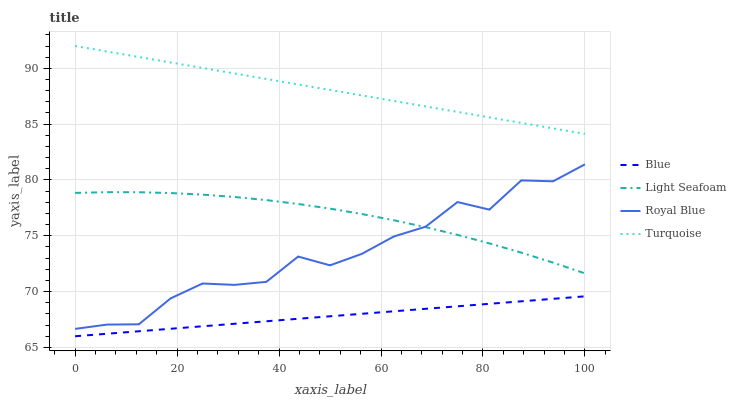Does Blue have the minimum area under the curve?
Answer yes or no. Yes. Does Turquoise have the maximum area under the curve?
Answer yes or no. Yes. Does Royal Blue have the minimum area under the curve?
Answer yes or no. No. Does Royal Blue have the maximum area under the curve?
Answer yes or no. No. Is Turquoise the smoothest?
Answer yes or no. Yes. Is Royal Blue the roughest?
Answer yes or no. Yes. Is Royal Blue the smoothest?
Answer yes or no. No. Is Turquoise the roughest?
Answer yes or no. No. Does Blue have the lowest value?
Answer yes or no. Yes. Does Royal Blue have the lowest value?
Answer yes or no. No. Does Turquoise have the highest value?
Answer yes or no. Yes. Does Royal Blue have the highest value?
Answer yes or no. No. Is Blue less than Royal Blue?
Answer yes or no. Yes. Is Turquoise greater than Blue?
Answer yes or no. Yes. Does Light Seafoam intersect Royal Blue?
Answer yes or no. Yes. Is Light Seafoam less than Royal Blue?
Answer yes or no. No. Is Light Seafoam greater than Royal Blue?
Answer yes or no. No. Does Blue intersect Royal Blue?
Answer yes or no. No. 